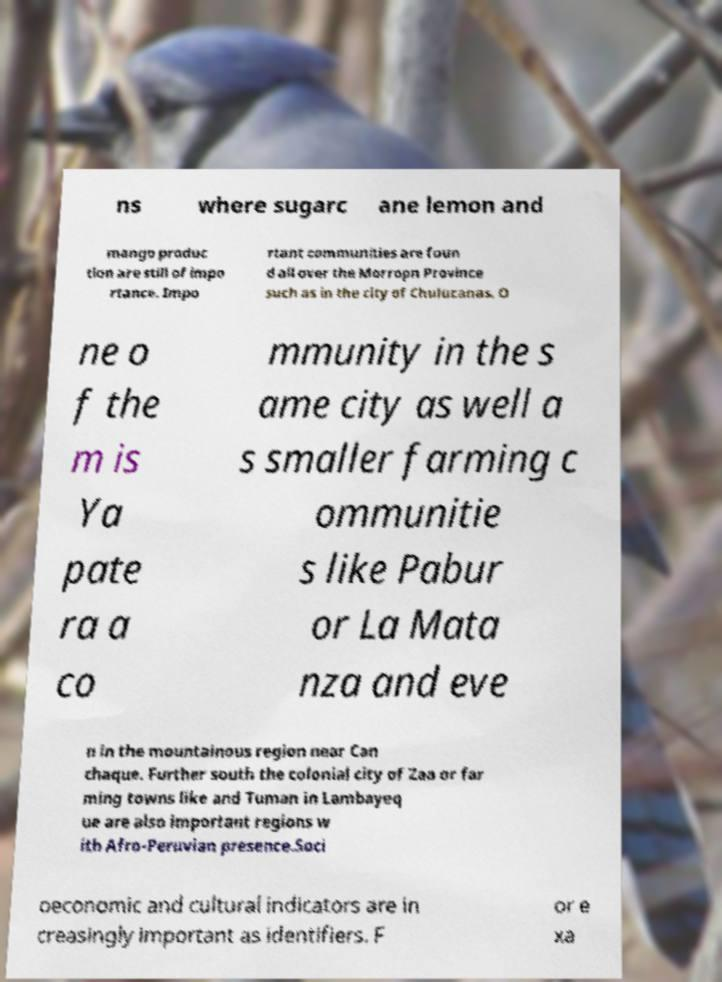Please identify and transcribe the text found in this image. ns where sugarc ane lemon and mango produc tion are still of impo rtance. Impo rtant communities are foun d all over the Morropn Province such as in the city of Chulucanas. O ne o f the m is Ya pate ra a co mmunity in the s ame city as well a s smaller farming c ommunitie s like Pabur or La Mata nza and eve n in the mountainous region near Can chaque. Further south the colonial city of Zaa or far ming towns like and Tuman in Lambayeq ue are also important regions w ith Afro-Peruvian presence.Soci oeconomic and cultural indicators are in creasingly important as identifiers. F or e xa 